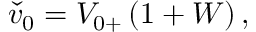<formula> <loc_0><loc_0><loc_500><loc_500>\begin{array} { r } { \check { v } _ { 0 } = { V } _ { 0 + } \left ( 1 + W \right ) , } \end{array}</formula> 